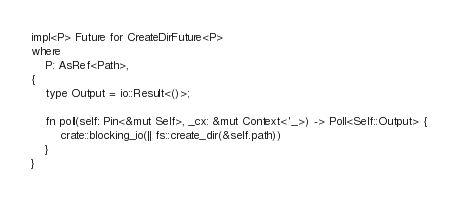<code> <loc_0><loc_0><loc_500><loc_500><_Rust_>impl<P> Future for CreateDirFuture<P>
where
    P: AsRef<Path>,
{
    type Output = io::Result<()>;

    fn poll(self: Pin<&mut Self>, _cx: &mut Context<'_>) -> Poll<Self::Output> {
        crate::blocking_io(|| fs::create_dir(&self.path))
    }
}
</code> 